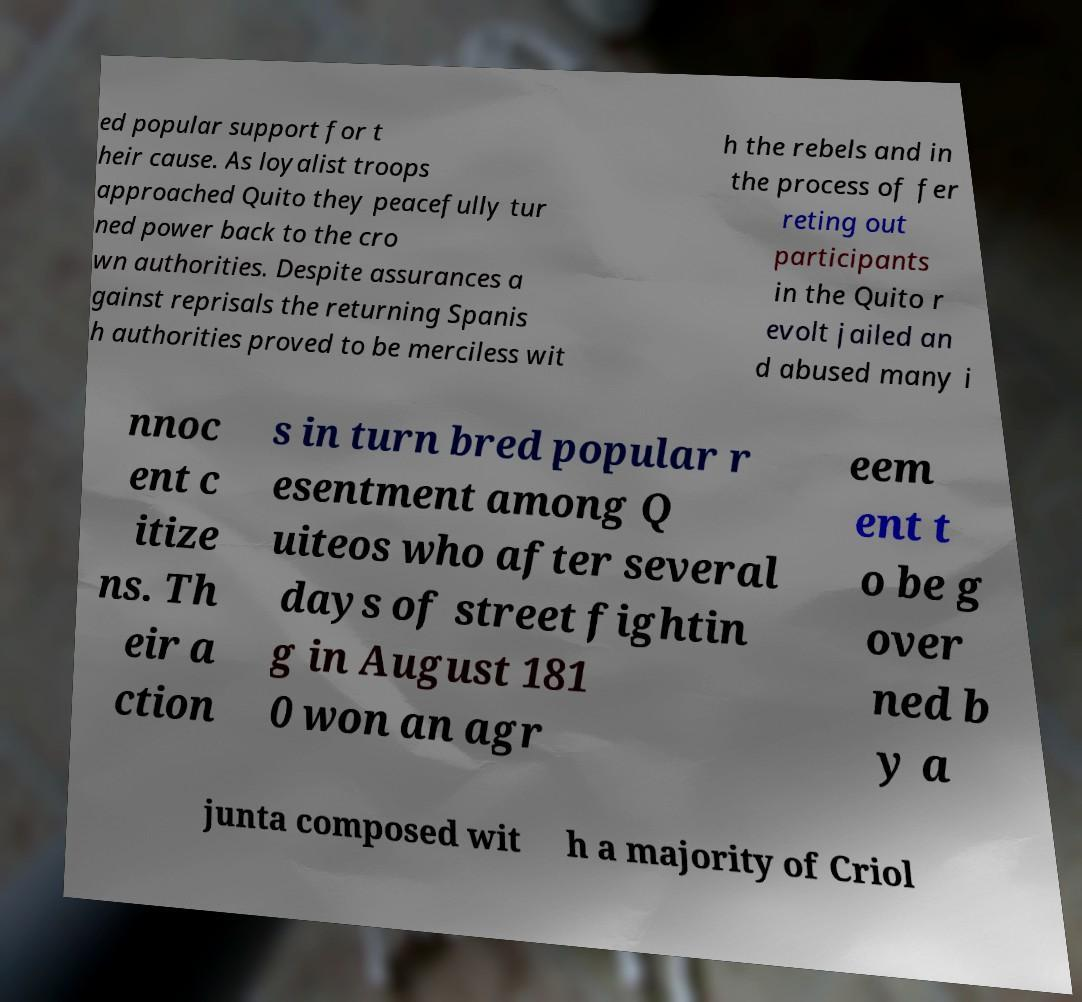What messages or text are displayed in this image? I need them in a readable, typed format. ed popular support for t heir cause. As loyalist troops approached Quito they peacefully tur ned power back to the cro wn authorities. Despite assurances a gainst reprisals the returning Spanis h authorities proved to be merciless wit h the rebels and in the process of fer reting out participants in the Quito r evolt jailed an d abused many i nnoc ent c itize ns. Th eir a ction s in turn bred popular r esentment among Q uiteos who after several days of street fightin g in August 181 0 won an agr eem ent t o be g over ned b y a junta composed wit h a majority of Criol 